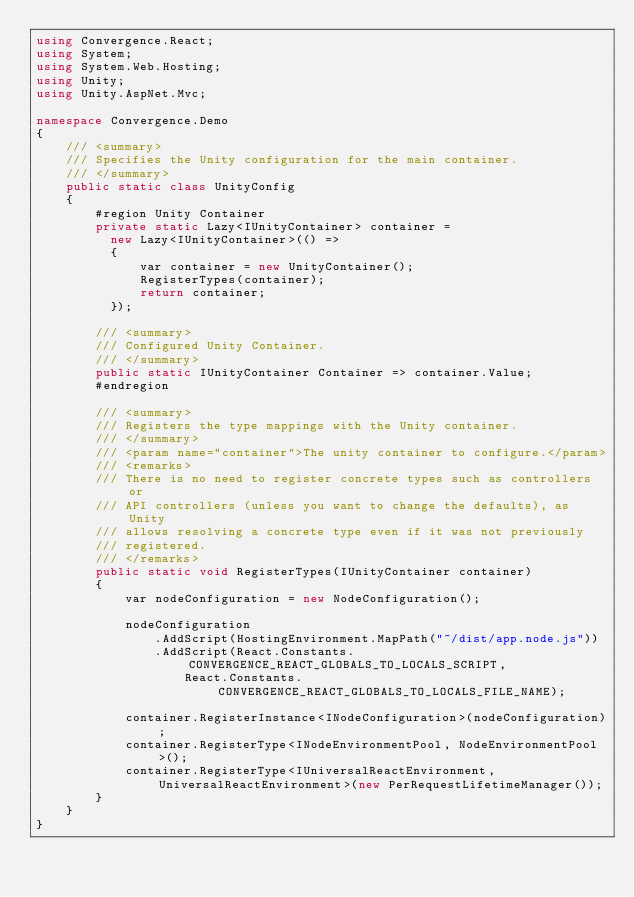<code> <loc_0><loc_0><loc_500><loc_500><_C#_>using Convergence.React;
using System;
using System.Web.Hosting;
using Unity;
using Unity.AspNet.Mvc;

namespace Convergence.Demo
{
    /// <summary>
    /// Specifies the Unity configuration for the main container.
    /// </summary>
    public static class UnityConfig
    {
        #region Unity Container
        private static Lazy<IUnityContainer> container =
          new Lazy<IUnityContainer>(() =>
          {
              var container = new UnityContainer();
              RegisterTypes(container);
              return container;
          });

        /// <summary>
        /// Configured Unity Container.
        /// </summary>
        public static IUnityContainer Container => container.Value;
        #endregion

        /// <summary>
        /// Registers the type mappings with the Unity container.
        /// </summary>
        /// <param name="container">The unity container to configure.</param>
        /// <remarks>
        /// There is no need to register concrete types such as controllers or
        /// API controllers (unless you want to change the defaults), as Unity
        /// allows resolving a concrete type even if it was not previously
        /// registered.
        /// </remarks>
        public static void RegisterTypes(IUnityContainer container)
        {
            var nodeConfiguration = new NodeConfiguration();

            nodeConfiguration
                .AddScript(HostingEnvironment.MapPath("~/dist/app.node.js"))
                .AddScript(React.Constants.CONVERGENCE_REACT_GLOBALS_TO_LOCALS_SCRIPT,
                    React.Constants.CONVERGENCE_REACT_GLOBALS_TO_LOCALS_FILE_NAME);

            container.RegisterInstance<INodeConfiguration>(nodeConfiguration);
            container.RegisterType<INodeEnvironmentPool, NodeEnvironmentPool>();
            container.RegisterType<IUniversalReactEnvironment, UniversalReactEnvironment>(new PerRequestLifetimeManager());
        }
    }
}</code> 